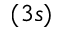Convert formula to latex. <formula><loc_0><loc_0><loc_500><loc_500>( 3 s )</formula> 